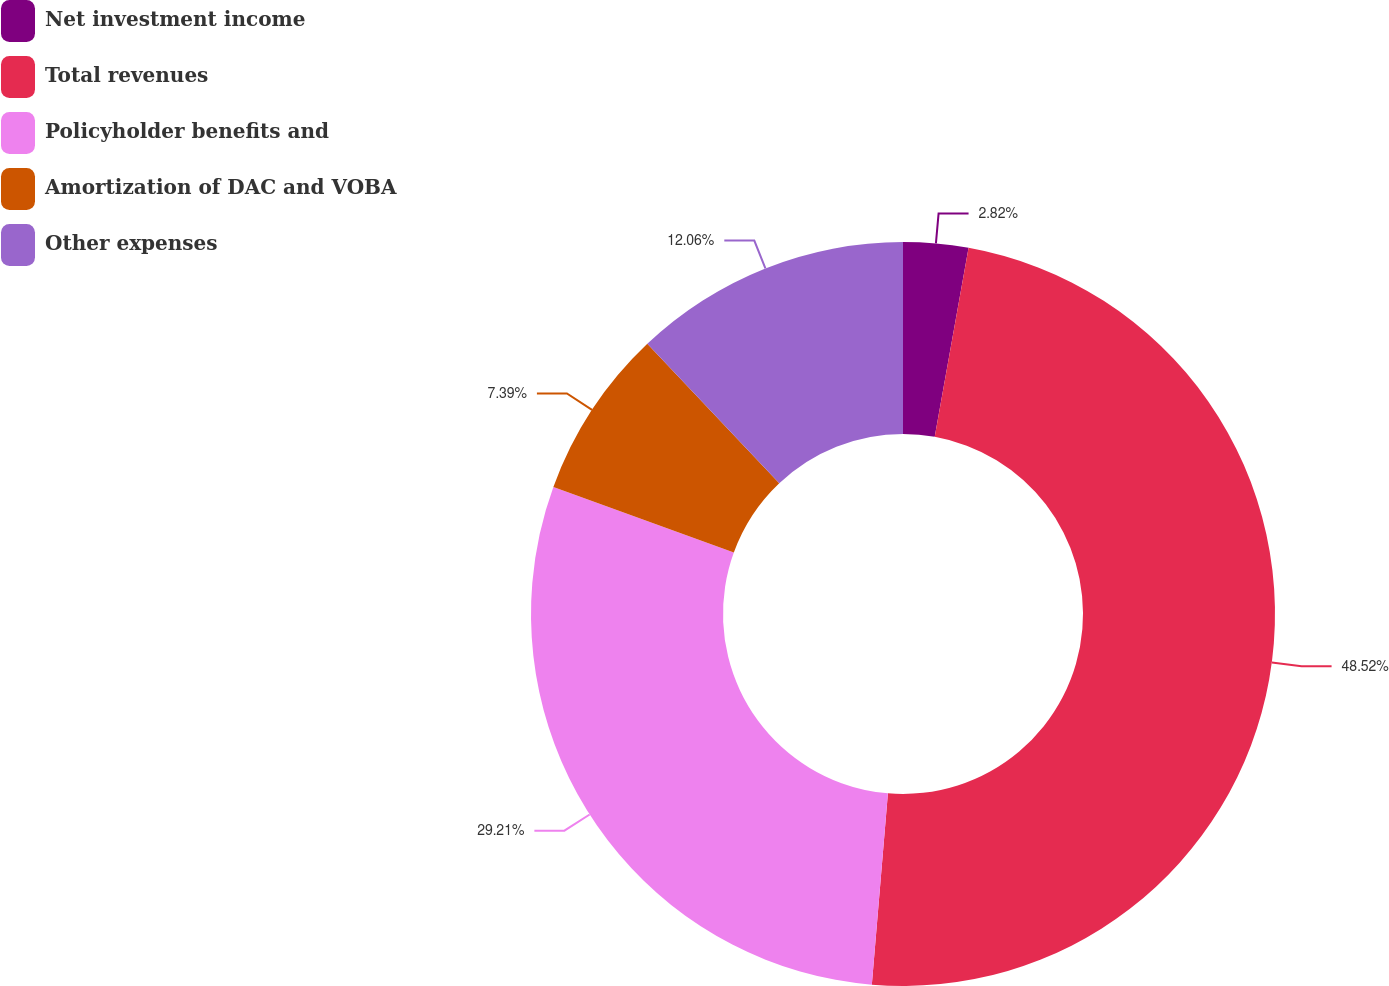Convert chart. <chart><loc_0><loc_0><loc_500><loc_500><pie_chart><fcel>Net investment income<fcel>Total revenues<fcel>Policyholder benefits and<fcel>Amortization of DAC and VOBA<fcel>Other expenses<nl><fcel>2.82%<fcel>48.51%<fcel>29.21%<fcel>7.39%<fcel>12.06%<nl></chart> 